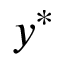Convert formula to latex. <formula><loc_0><loc_0><loc_500><loc_500>y ^ { * }</formula> 